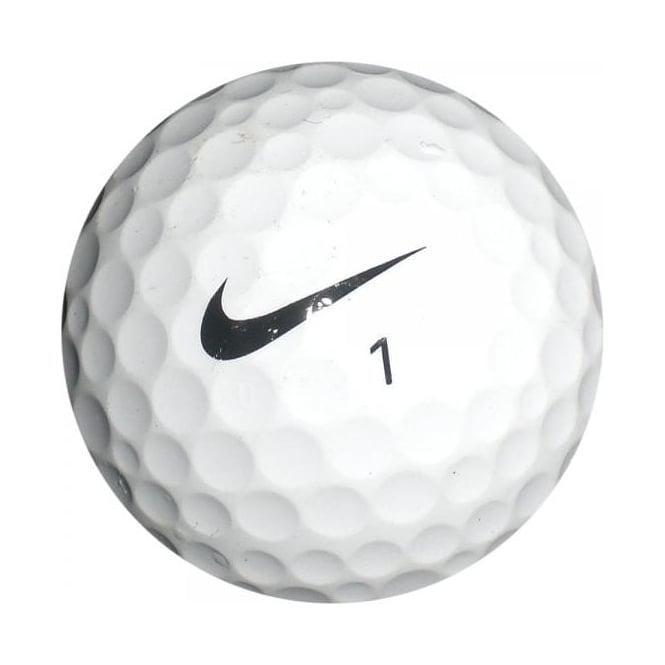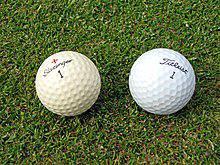The first image is the image on the left, the second image is the image on the right. Analyze the images presented: Is the assertion "The right image contains no less than two golf balls." valid? Answer yes or no. Yes. 